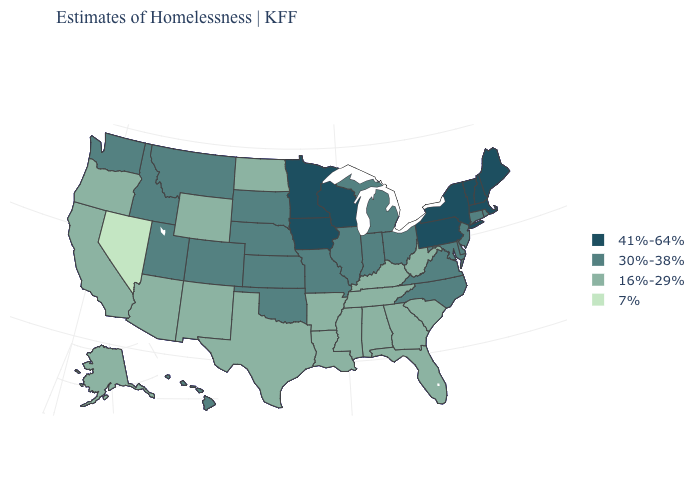Name the states that have a value in the range 16%-29%?
Short answer required. Alabama, Alaska, Arizona, Arkansas, California, Florida, Georgia, Kentucky, Louisiana, Mississippi, New Mexico, North Dakota, Oregon, South Carolina, Tennessee, Texas, West Virginia, Wyoming. How many symbols are there in the legend?
Be succinct. 4. Name the states that have a value in the range 41%-64%?
Concise answer only. Iowa, Maine, Massachusetts, Minnesota, New Hampshire, New York, Pennsylvania, Vermont, Wisconsin. What is the lowest value in the USA?
Keep it brief. 7%. Name the states that have a value in the range 41%-64%?
Give a very brief answer. Iowa, Maine, Massachusetts, Minnesota, New Hampshire, New York, Pennsylvania, Vermont, Wisconsin. Which states have the lowest value in the South?
Answer briefly. Alabama, Arkansas, Florida, Georgia, Kentucky, Louisiana, Mississippi, South Carolina, Tennessee, Texas, West Virginia. Does the map have missing data?
Quick response, please. No. What is the value of New Jersey?
Quick response, please. 30%-38%. Does Michigan have a higher value than Vermont?
Be succinct. No. Among the states that border Illinois , does Missouri have the highest value?
Short answer required. No. Name the states that have a value in the range 41%-64%?
Keep it brief. Iowa, Maine, Massachusetts, Minnesota, New Hampshire, New York, Pennsylvania, Vermont, Wisconsin. Among the states that border Rhode Island , which have the highest value?
Give a very brief answer. Massachusetts. What is the lowest value in the MidWest?
Quick response, please. 16%-29%. Which states have the highest value in the USA?
Quick response, please. Iowa, Maine, Massachusetts, Minnesota, New Hampshire, New York, Pennsylvania, Vermont, Wisconsin. 